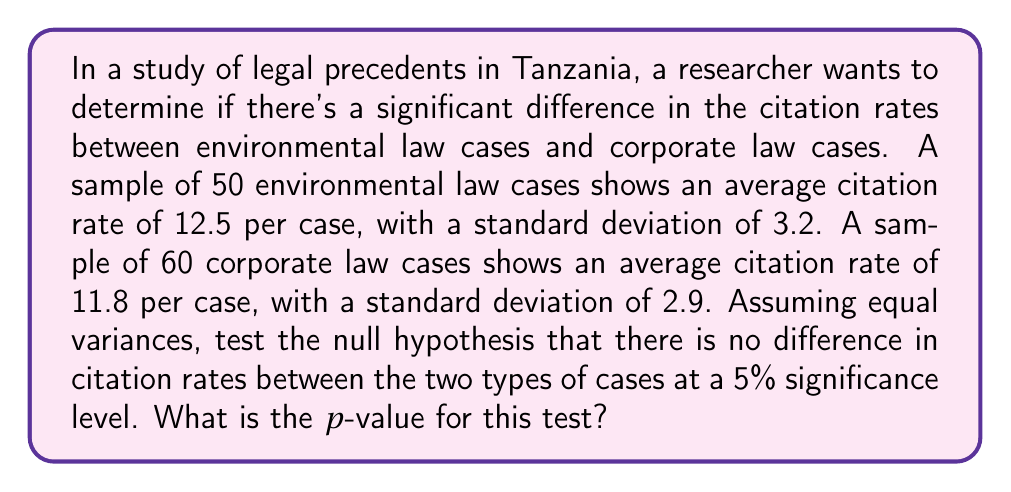What is the answer to this math problem? Let's approach this step-by-step:

1) First, we need to identify the appropriate test. Since we're comparing two independent groups and assuming equal variances, we'll use a two-sample t-test.

2) Let's define our hypotheses:
   $H_0: \mu_1 - \mu_2 = 0$ (no difference in citation rates)
   $H_a: \mu_1 - \mu_2 \neq 0$ (there is a difference in citation rates)

3) We'll use the t-statistic formula:

   $$t = \frac{\bar{x}_1 - \bar{x}_2}{s_p \sqrt{\frac{1}{n_1} + \frac{1}{n_2}}}$$

   where $s_p$ is the pooled standard deviation.

4) Calculate the pooled standard deviation:

   $$s_p = \sqrt{\frac{(n_1-1)s_1^2 + (n_2-1)s_2^2}{n_1 + n_2 - 2}}$$

   $$s_p = \sqrt{\frac{(50-1)(3.2)^2 + (60-1)(2.9)^2}{50 + 60 - 2}} = 3.04$$

5) Now, calculate the t-statistic:

   $$t = \frac{12.5 - 11.8}{3.04 \sqrt{\frac{1}{50} + \frac{1}{60}}} = 1.28$$

6) The degrees of freedom are $n_1 + n_2 - 2 = 50 + 60 - 2 = 108$

7) To find the p-value, we need to use a t-distribution table or calculator. For a two-tailed test with 108 degrees of freedom and t = 1.28, the p-value is approximately 0.2034.
Answer: 0.2034 